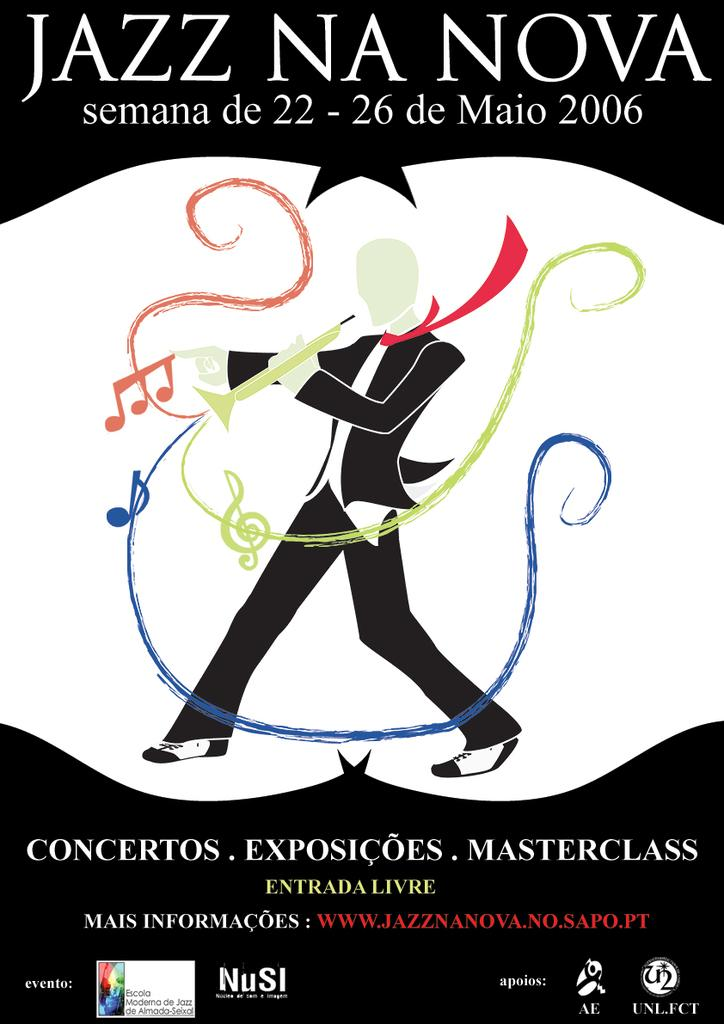What is present on the poster in the image? There is a poster in the image, which contains a picture and text. Can you describe the picture on the poster? The provided facts do not specify the content of the picture on the poster. What information is conveyed through the text on the poster? The provided facts do not specify the content of the text on the poster. How does the wine on the poster interact with the people in the image? There is no wine present in the image, as the provided facts only mention a poster containing a picture and text. 